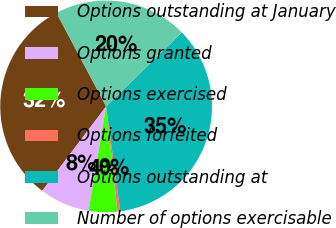<chart> <loc_0><loc_0><loc_500><loc_500><pie_chart><fcel>Options outstanding at January<fcel>Options granted<fcel>Options exercised<fcel>Options forfeited<fcel>Options outstanding at<fcel>Number of options exercisable<nl><fcel>31.92%<fcel>7.65%<fcel>4.38%<fcel>0.42%<fcel>35.19%<fcel>20.44%<nl></chart> 